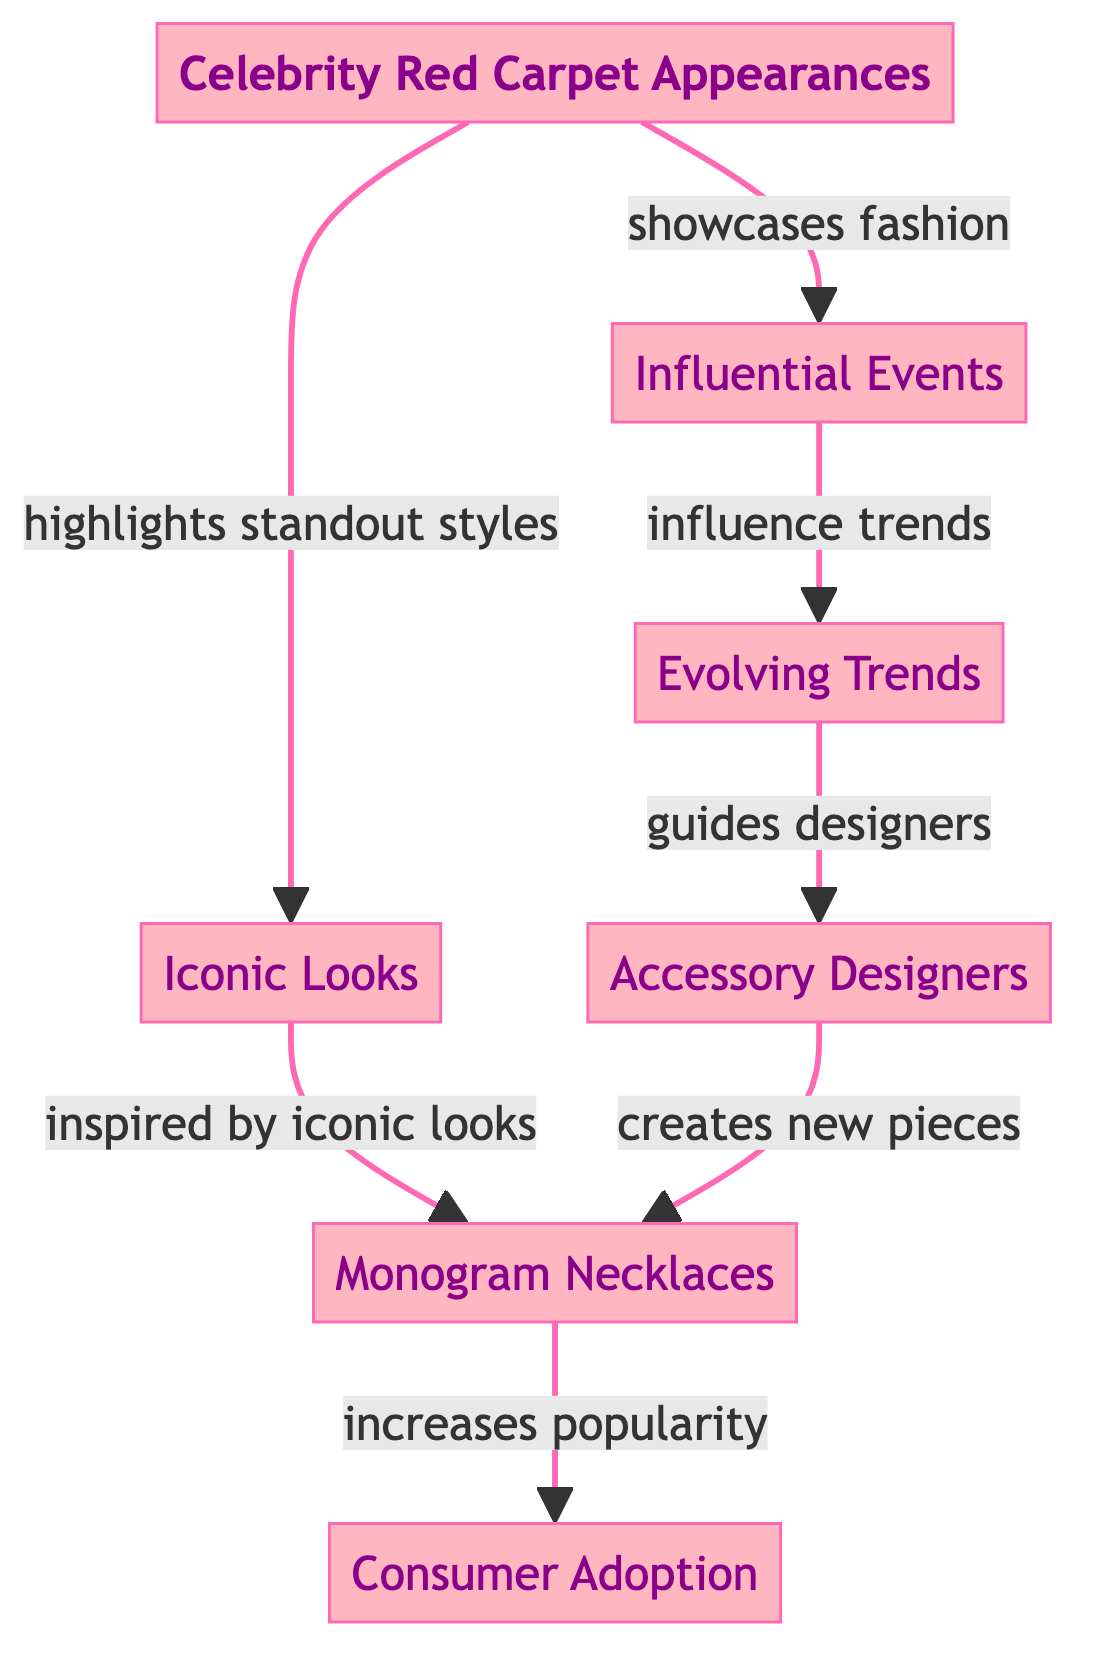What is the central node in the diagram? The diagram features "Celebrity Red Carpet Appearances" as the main node, branching out to other related nodes. It is visually highlighted and positioned at the center of the diagram.
Answer: Celebrity Red Carpet Appearances How many nodes are present in the diagram? By counting the circles in the diagram, we find there are six nodes: Celebrity Red Carpet Appearances, Influential Events, Iconic Looks, Evolving Trends, Accessory Designers, and Monogram Necklaces.
Answer: Six Which node is directly linked to both "Iconic Looks" and "Accessory Designers"? By reviewing the connections, "Evolving Trends" is the node connecting both "Iconic Looks" and "Accessory Designers", as it is influenced by the former and guides the latter.
Answer: Evolving Trends What effect do "Accessory Designers" have according to the diagram? The diagram illustrates that "Accessory Designers" create new pieces, which in turn includes monogram necklaces, highlighting their role in accessory innovation.
Answer: Creates new pieces What is the relationship between "Celebrity Red Carpet Appearances" and "Consumer Adoption"? The flowchart shows a progression where "Celebrity Red Carpet Appearances" leads to the development of accessory trends and increased popularity, which ultimately results in "Consumer Adoption" as the final outcome.
Answer: Increases popularity How does "Iconic Looks" influence "Monogram Necklaces"? "Iconic Looks" inspires the creation and trend adoption of "Monogram Necklaces", as shown by the directed connection from "Iconic Looks" to "Monogram Necklaces".
Answer: Inspired by iconic looks What guides accessory designers? The connection in the diagram indicates that "Evolving Trends" serves as a guideline for designers, showing how trends evolve and shape new designs.
Answer: Evolving Trends Which node represents a consumer behavior outcome? "Consumer Adoption" is the final node in the flow, indicating the acceptance and purchase behavior of consumers based on the trends established by earlier nodes.
Answer: Consumer Adoption What type of accessory is specifically mentioned in the diagram? The node "Monogram Necklaces" explicitly names a type of accessory that has gained popularity over the past decade within the context of celebrity influence.
Answer: Monogram Necklaces 